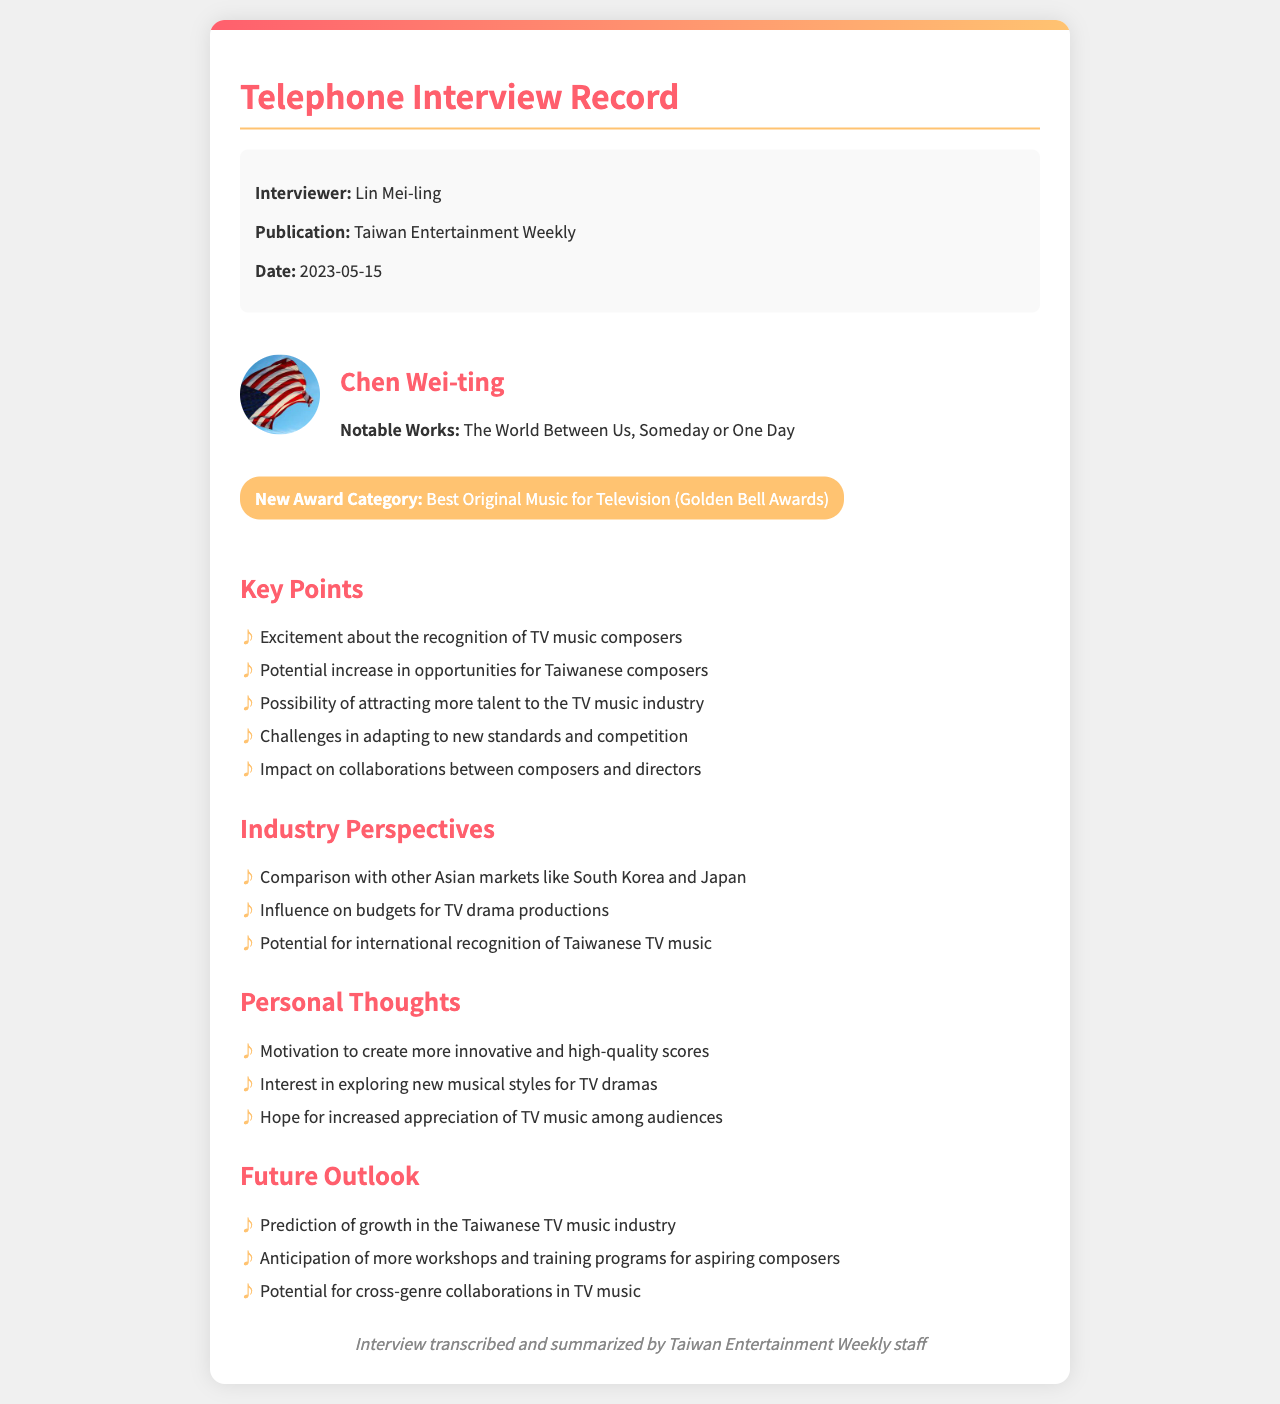what is the name of the interviewer? The interviewer's name is provided in the document under interview details.
Answer: Lin Mei-ling what is the date of the interview? The date of the interview is mentioned in the interview details section of the document.
Answer: 2023-05-15 what is the new award category? The new award category is highlighted in a specific section of the document.
Answer: Best Original Music for Television (Golden Bell Awards) who is the composer interviewed? The composer's name is prominently displayed in the composer information section.
Answer: Chen Wei-ting what notable works are mentioned? The notable works of the composer are listed in the composer information section.
Answer: The World Between Us, Someday or One Day what is one potential impact of the new award on the TV music industry? Several potential impacts are enumerated in the key points section of the document.
Answer: Potential increase in opportunities for Taiwanese composers how might the new award influence budget allocations for productions? The effect of the new award on budgets is addressed in the industry perspectives section.
Answer: Influence on budgets for TV drama productions what is a personal thought expressed by the composer? The composer's personal thoughts on creating music are outlined in a dedicated section.
Answer: Motivation to create more innovative and high-quality scores what future outlook is predicted for the Taiwanese TV music industry? The future outlook includes several predicted trends and changes detailed in the document.
Answer: Prediction of growth in the Taiwanese TV music industry 